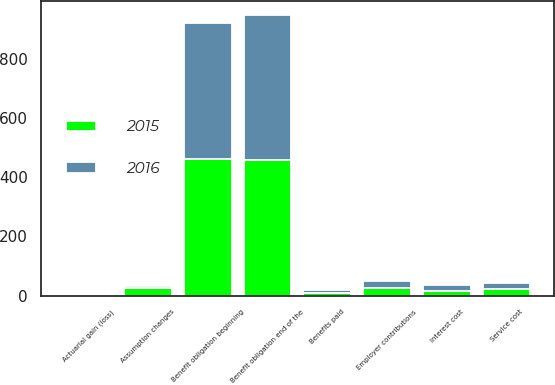Convert chart. <chart><loc_0><loc_0><loc_500><loc_500><stacked_bar_chart><ecel><fcel>Benefit obligation beginning<fcel>Service cost<fcel>Interest cost<fcel>Benefits paid<fcel>Actuarial gain (loss)<fcel>Assumption changes<fcel>Benefit obligation end of the<fcel>Employer contributions<nl><fcel>2016<fcel>459.2<fcel>20.1<fcel>18.2<fcel>9.9<fcel>4.2<fcel>6.1<fcel>489.5<fcel>26.4<nl><fcel>2015<fcel>461.8<fcel>21.6<fcel>16.9<fcel>7.5<fcel>1.9<fcel>25.3<fcel>459.2<fcel>24.4<nl></chart> 